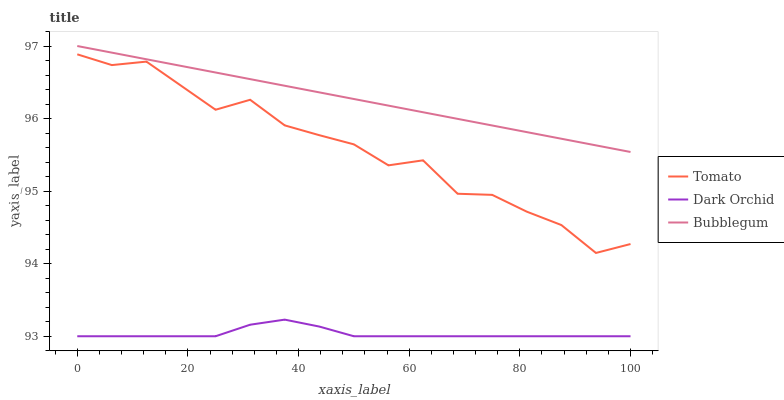Does Bubblegum have the minimum area under the curve?
Answer yes or no. No. Does Dark Orchid have the maximum area under the curve?
Answer yes or no. No. Is Dark Orchid the smoothest?
Answer yes or no. No. Is Dark Orchid the roughest?
Answer yes or no. No. Does Bubblegum have the lowest value?
Answer yes or no. No. Does Dark Orchid have the highest value?
Answer yes or no. No. Is Dark Orchid less than Bubblegum?
Answer yes or no. Yes. Is Bubblegum greater than Dark Orchid?
Answer yes or no. Yes. Does Dark Orchid intersect Bubblegum?
Answer yes or no. No. 